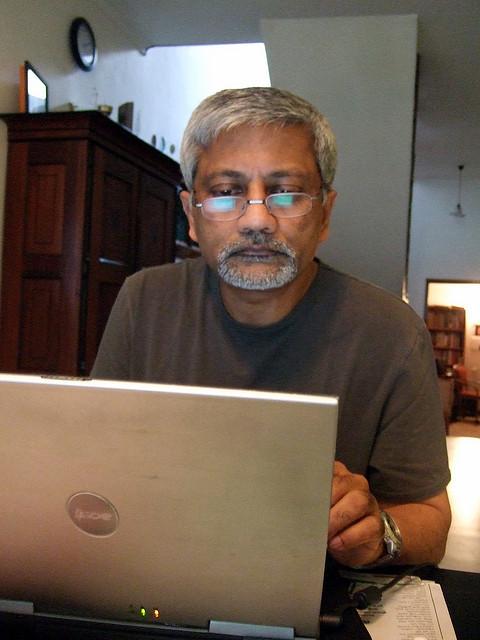Is the man's beard gray?
Short answer required. Yes. Where is a clock?
Keep it brief. Wall. Is the man working on something important?
Keep it brief. Yes. 